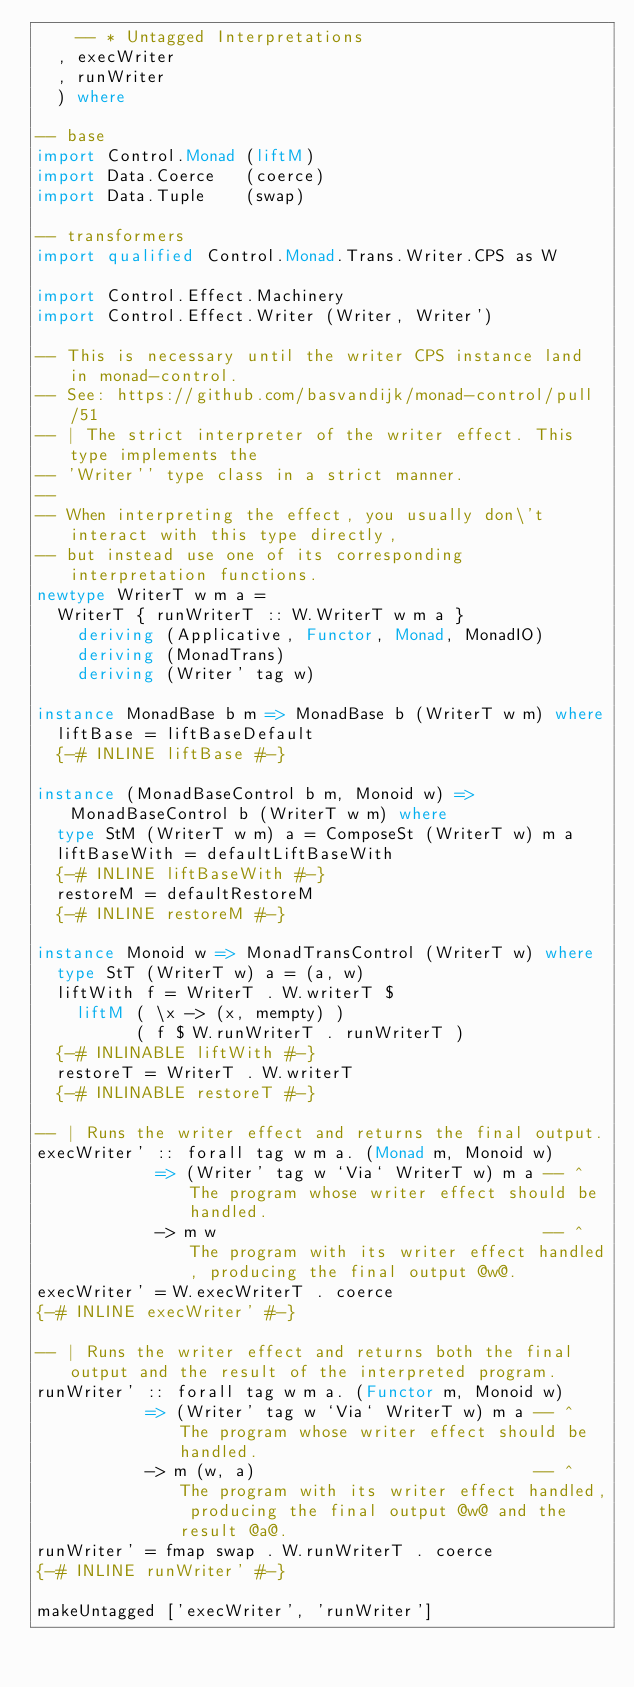<code> <loc_0><loc_0><loc_500><loc_500><_Haskell_>    -- * Untagged Interpretations
  , execWriter
  , runWriter
  ) where

-- base
import Control.Monad (liftM)
import Data.Coerce   (coerce)
import Data.Tuple    (swap)

-- transformers
import qualified Control.Monad.Trans.Writer.CPS as W

import Control.Effect.Machinery
import Control.Effect.Writer (Writer, Writer')

-- This is necessary until the writer CPS instance land in monad-control.
-- See: https://github.com/basvandijk/monad-control/pull/51
-- | The strict interpreter of the writer effect. This type implements the
-- 'Writer'' type class in a strict manner.
--
-- When interpreting the effect, you usually don\'t interact with this type directly,
-- but instead use one of its corresponding interpretation functions.
newtype WriterT w m a =
  WriterT { runWriterT :: W.WriterT w m a }
    deriving (Applicative, Functor, Monad, MonadIO)
    deriving (MonadTrans)
    deriving (Writer' tag w)

instance MonadBase b m => MonadBase b (WriterT w m) where
  liftBase = liftBaseDefault
  {-# INLINE liftBase #-}

instance (MonadBaseControl b m, Monoid w) => MonadBaseControl b (WriterT w m) where
  type StM (WriterT w m) a = ComposeSt (WriterT w) m a
  liftBaseWith = defaultLiftBaseWith
  {-# INLINE liftBaseWith #-}
  restoreM = defaultRestoreM
  {-# INLINE restoreM #-}

instance Monoid w => MonadTransControl (WriterT w) where
  type StT (WriterT w) a = (a, w)
  liftWith f = WriterT . W.writerT $
    liftM ( \x -> (x, mempty) )
          ( f $ W.runWriterT . runWriterT )
  {-# INLINABLE liftWith #-}
  restoreT = WriterT . W.writerT
  {-# INLINABLE restoreT #-}

-- | Runs the writer effect and returns the final output.
execWriter' :: forall tag w m a. (Monad m, Monoid w)
            => (Writer' tag w `Via` WriterT w) m a -- ^ The program whose writer effect should be handled.
            -> m w                                 -- ^ The program with its writer effect handled, producing the final output @w@.
execWriter' = W.execWriterT . coerce
{-# INLINE execWriter' #-}

-- | Runs the writer effect and returns both the final output and the result of the interpreted program.
runWriter' :: forall tag w m a. (Functor m, Monoid w)
           => (Writer' tag w `Via` WriterT w) m a -- ^ The program whose writer effect should be handled.
           -> m (w, a)                            -- ^ The program with its writer effect handled, producing the final output @w@ and the result @a@.
runWriter' = fmap swap . W.runWriterT . coerce
{-# INLINE runWriter' #-}

makeUntagged ['execWriter', 'runWriter']</code> 